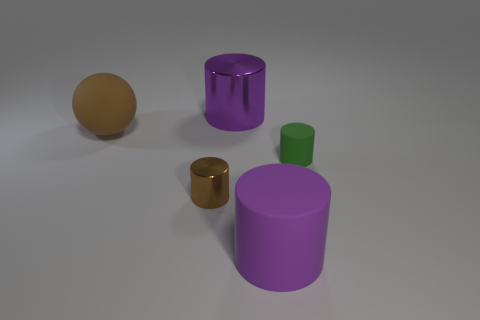Is there a big rubber cylinder of the same color as the rubber ball?
Keep it short and to the point. No. Is the shape of the purple shiny thing the same as the green thing?
Your answer should be very brief. Yes. How many large objects are either purple rubber cylinders or metal things?
Offer a very short reply. 2. What color is the other cylinder that is made of the same material as the brown cylinder?
Your response must be concise. Purple. How many other balls are made of the same material as the brown sphere?
Ensure brevity in your answer.  0. Is the size of the purple cylinder that is behind the brown cylinder the same as the cylinder in front of the tiny brown shiny thing?
Offer a very short reply. Yes. The tiny cylinder that is to the left of the rubber cylinder that is behind the small brown thing is made of what material?
Ensure brevity in your answer.  Metal. Are there fewer large purple rubber objects that are left of the big brown sphere than green rubber objects that are on the left side of the purple metallic cylinder?
Provide a succinct answer. No. There is another big cylinder that is the same color as the large matte cylinder; what is it made of?
Make the answer very short. Metal. Is there any other thing that is the same shape as the brown rubber object?
Your answer should be compact. No. 